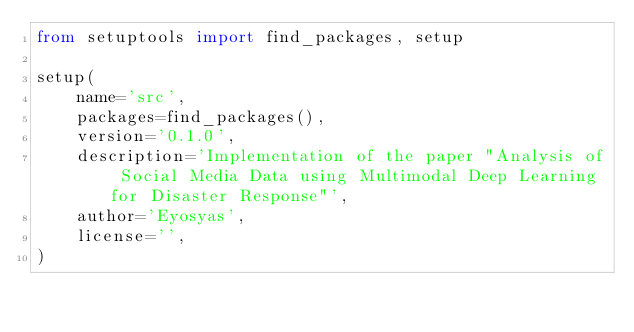Convert code to text. <code><loc_0><loc_0><loc_500><loc_500><_Python_>from setuptools import find_packages, setup

setup(
    name='src',
    packages=find_packages(),
    version='0.1.0',
    description='Implementation of the paper "Analysis of Social Media Data using Multimodal Deep Learning for Disaster Response"',
    author='Eyosyas',
    license='',
)
</code> 